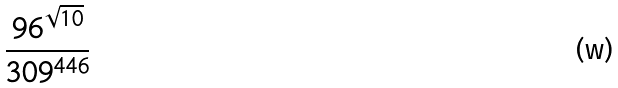Convert formula to latex. <formula><loc_0><loc_0><loc_500><loc_500>\frac { 9 6 ^ { \sqrt { 1 0 } } } { 3 0 9 ^ { 4 4 6 } }</formula> 